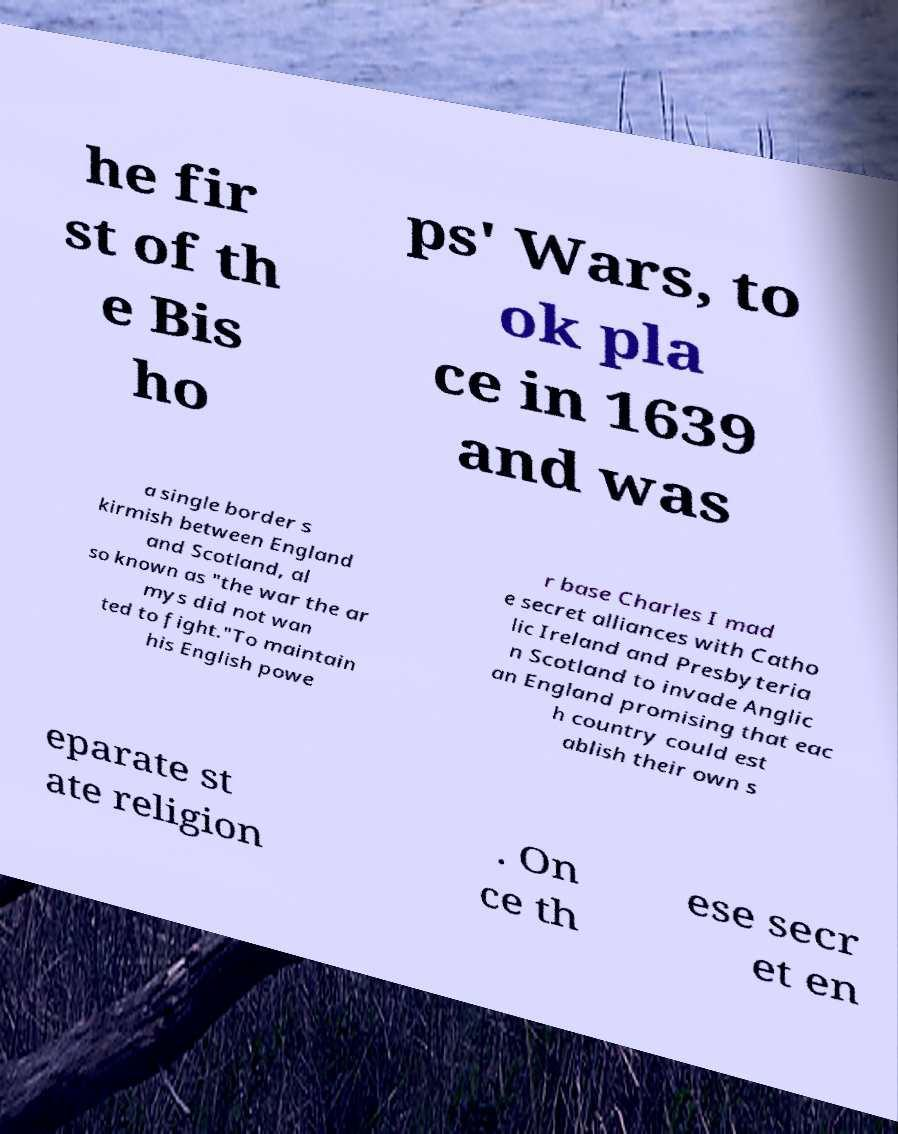Can you read and provide the text displayed in the image?This photo seems to have some interesting text. Can you extract and type it out for me? he fir st of th e Bis ho ps' Wars, to ok pla ce in 1639 and was a single border s kirmish between England and Scotland, al so known as "the war the ar mys did not wan ted to fight."To maintain his English powe r base Charles I mad e secret alliances with Catho lic Ireland and Presbyteria n Scotland to invade Anglic an England promising that eac h country could est ablish their own s eparate st ate religion . On ce th ese secr et en 